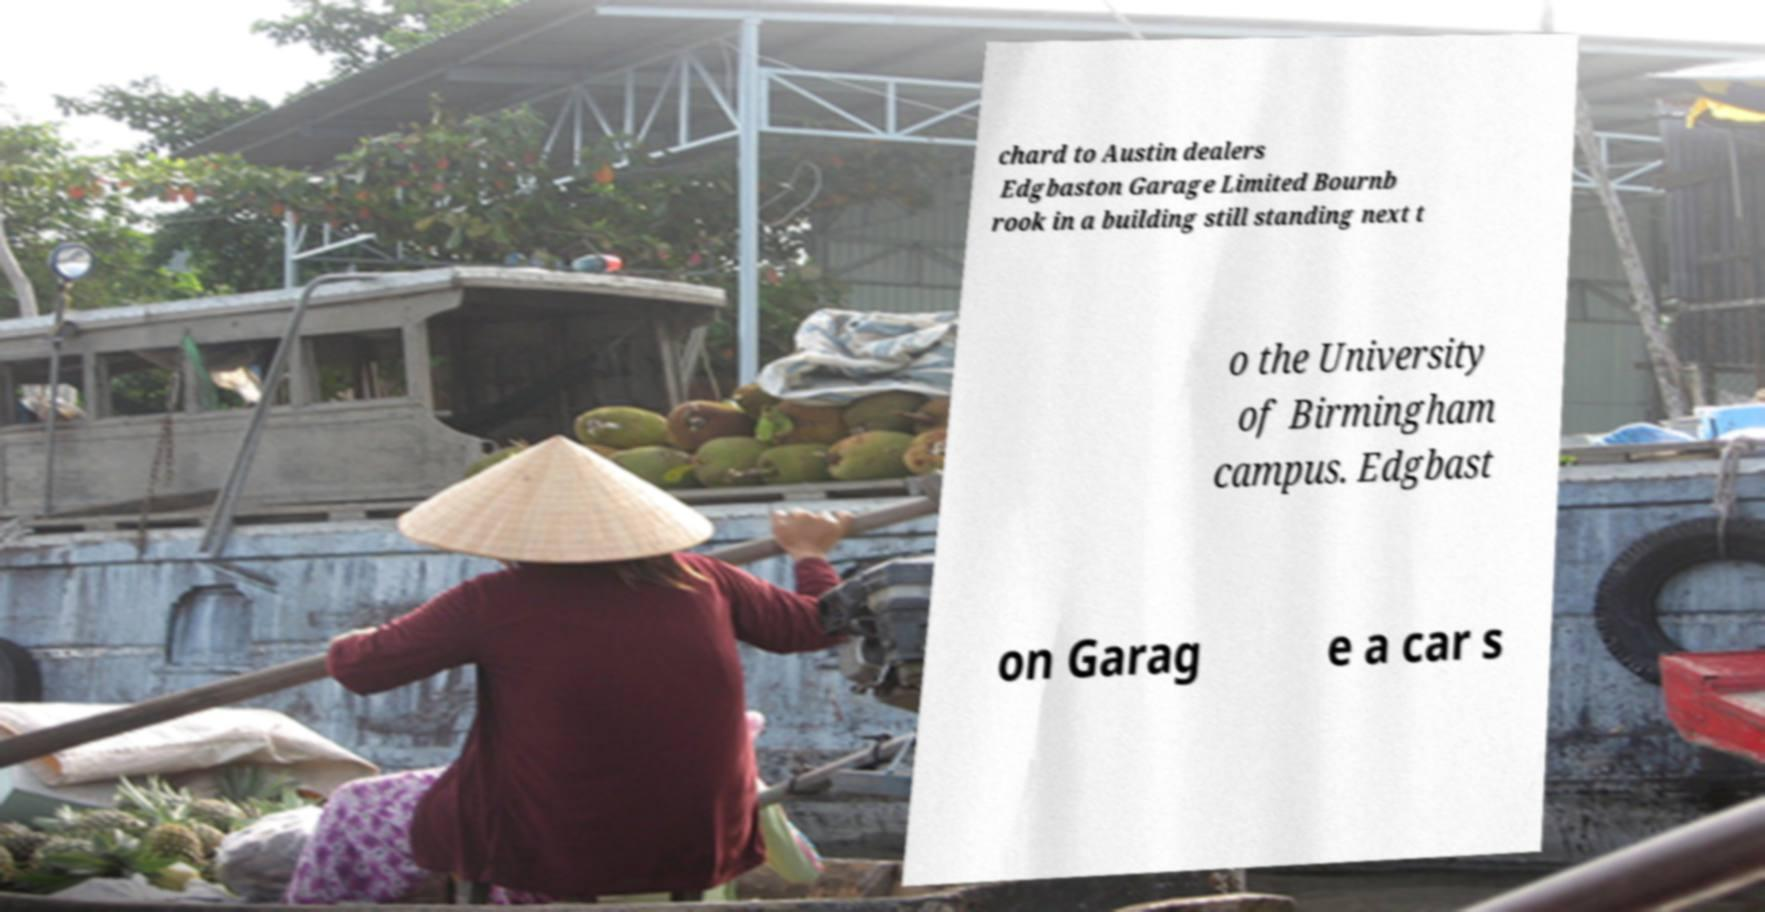Can you read and provide the text displayed in the image?This photo seems to have some interesting text. Can you extract and type it out for me? chard to Austin dealers Edgbaston Garage Limited Bournb rook in a building still standing next t o the University of Birmingham campus. Edgbast on Garag e a car s 